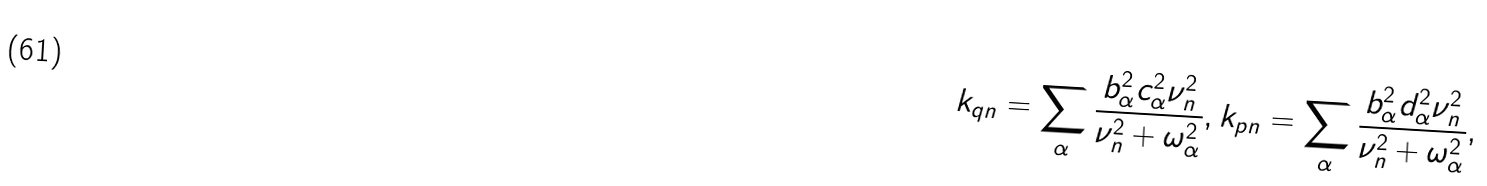<formula> <loc_0><loc_0><loc_500><loc_500>k _ { q n } = \sum _ { \alpha } \frac { b _ { \alpha } ^ { 2 } c _ { \alpha } ^ { 2 } \nu _ { n } ^ { 2 } } { \nu _ { n } ^ { 2 } + \omega _ { \alpha } ^ { 2 } } , k _ { p n } = \sum _ { \alpha } \frac { b _ { \alpha } ^ { 2 } d _ { \alpha } ^ { 2 } \nu _ { n } ^ { 2 } } { \nu _ { n } ^ { 2 } + \omega _ { \alpha } ^ { 2 } } ,</formula> 